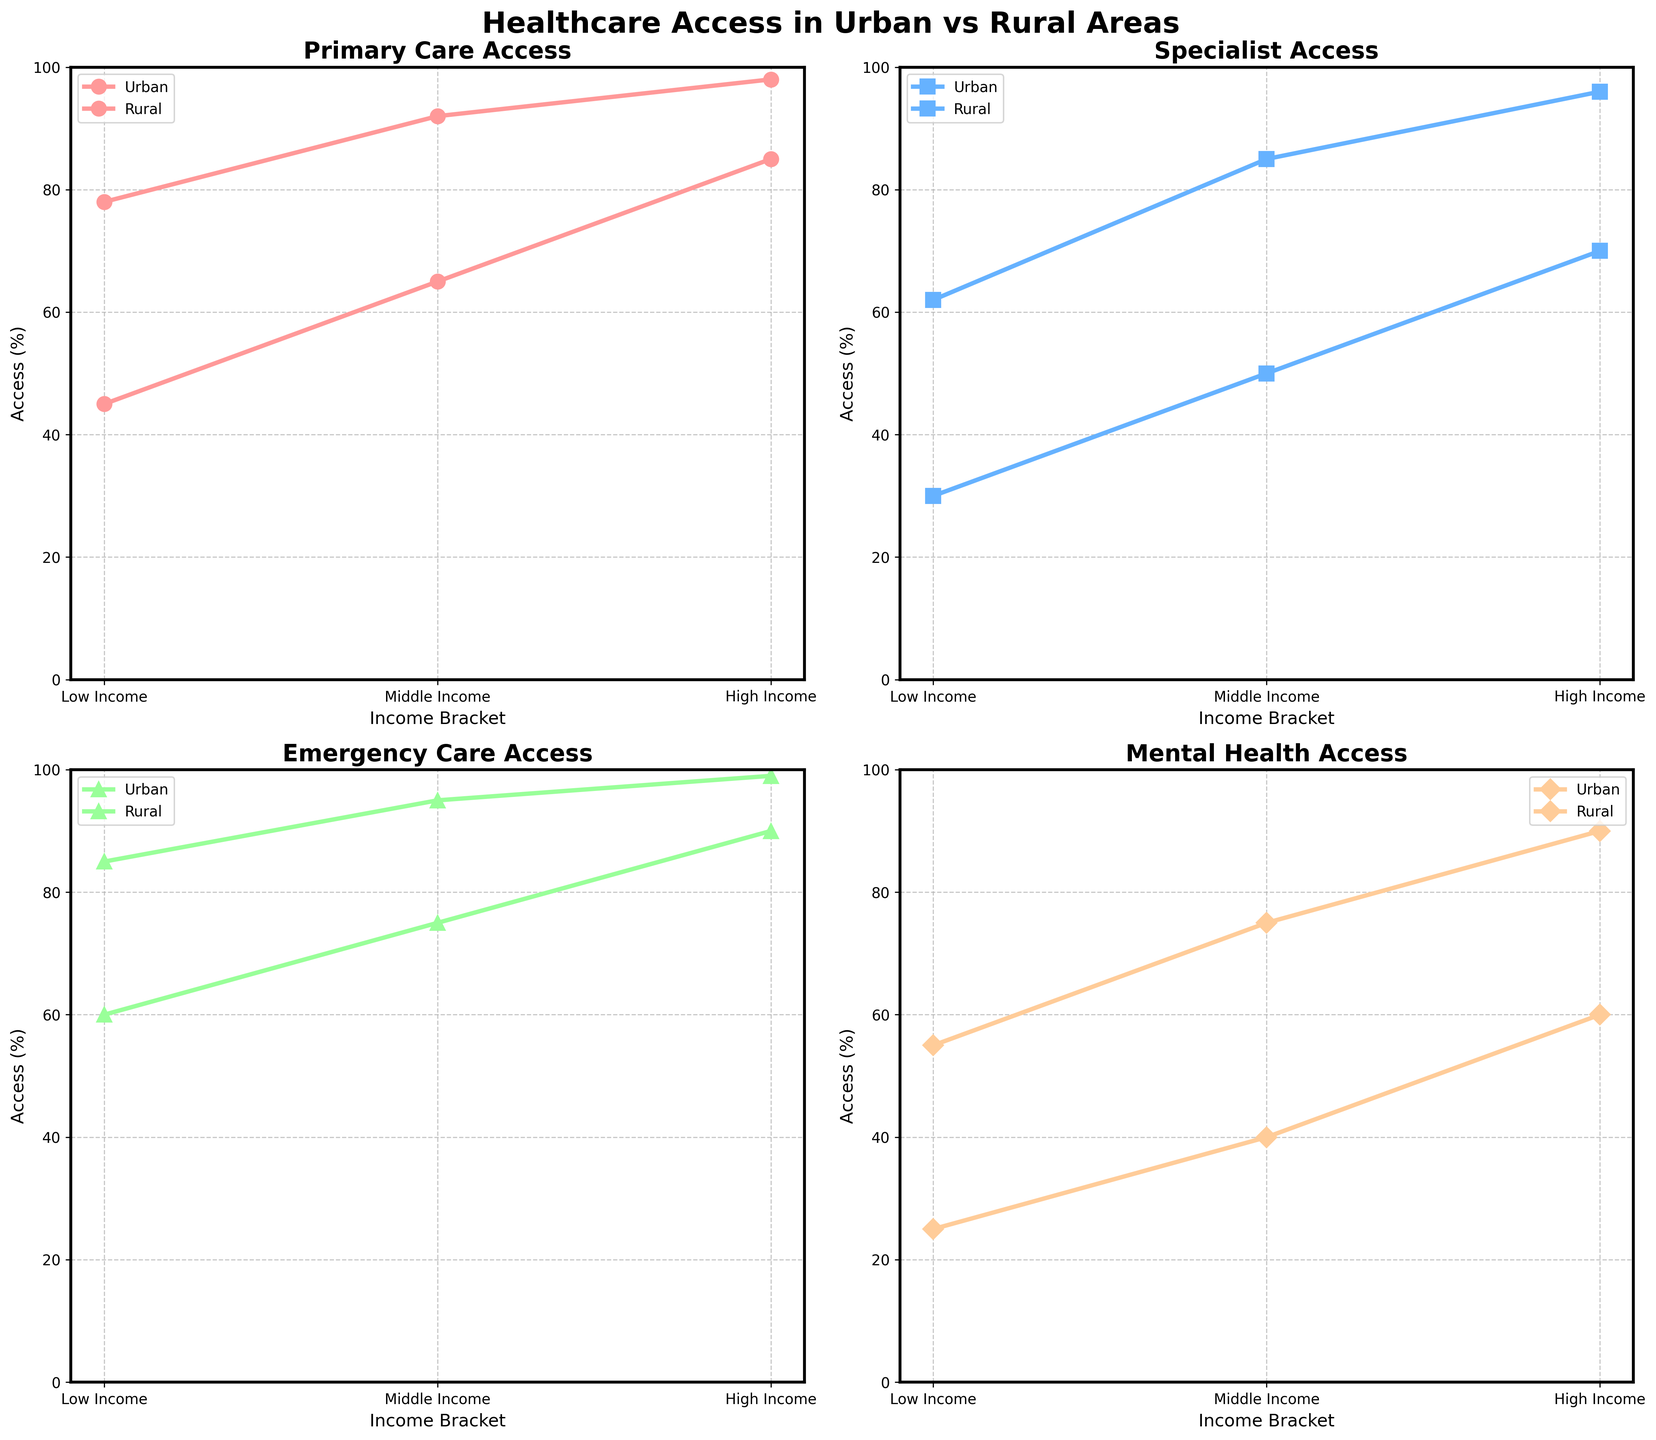What is the title of the entire figure? The title of the figure is located at the top and is the largest text, usually in bold. It helps summarize the entire plot in a single phrase. In this case, it reads "Healthcare Access in Urban vs Rural Areas".
Answer: Healthcare Access in Urban vs Rural Areas How does primary care access for high-income brackets compare between urban and rural areas? To compare the primary care access for high-income brackets, look at the points corresponding to "High Income" on the Primary Care Access subplot. In the urban category, it's at 98%, while in the rural category, it's at 85%.
Answer: Urban areas have higher primary care access What is the approximate difference in mental health access between low-income urban and rural areas? To find the difference, identify the mental health access percentages for low-income brackets in urban and rural areas. For urban, it's 55%, and for rural, it's 25%. The difference is 55% - 25% = 30%.
Answer: 30% Which income bracket sees the smallest difference in specialist access between urban and rural areas? Examine the Specialist Access subplot. For low income, the difference is 62% - 30% = 32%. For middle income, it's 85% - 50% = 35%. For high income, it's 96% - 70% = 26%. The smallest difference is for the high-income bracket.
Answer: High income Is specialist access consistently higher in urban areas across all income brackets? Analyze the Specialist Access subplot. For each income bracket (Low, Middle, High), compare urban and rural data points. In all cases (62% vs. 30%, 85% vs. 50%, 96% vs. 70%), urban specialist access is higher.
Answer: Yes What can be said about emergency care access for middle-income brackets in urban versus rural areas? Look at the Emergency Care Access subplot. For middle-income brackets, urban areas have 95%, while rural areas have 75%. Urban access is higher by 20%.
Answer: Urban areas have higher emergency care access What trend is observed in primary care access as income increases within rural areas? On the Primary Care Access subplot for rural regions, observe the trend across income brackets. As income moves from Low (45%) to Middle (65%) to High (85%), access consistently increases.
Answer: Access increases with income How does mental health access for middle-income rural areas compare to high-income urban areas? Look at the Mental Health Access subplot. Middle-income rural areas have 40% access, while high-income urban areas have 90% access. High-income urban access is much higher.
Answer: High-income urban is much higher Which type of healthcare access shows the largest disparity between high-income urban and rural areas? For each type of healthcare access (Primary Care, Specialist, Emergency, Mental Health), calculate the difference between high-income urban and rural values: Primary Care (98% vs. 85% = 13%), Specialist (96% vs. 70% = 26%), Emergency Care (99% vs. 90% = 9%), Mental Health (90% vs. 60% = 30%). The largest disparity is in Mental Health Access.
Answer: Mental Health Access What percentage of low-income rural areas have access to emergency care? Check the value on the Emergency Care Access subplot corresponding to low-income rural areas. The value is 60%.
Answer: 60% 